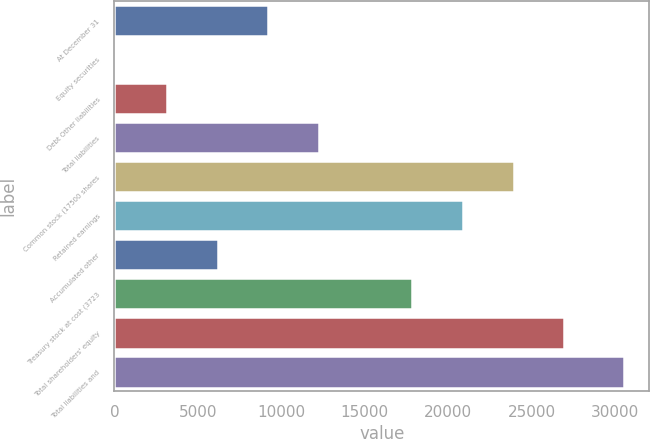<chart> <loc_0><loc_0><loc_500><loc_500><bar_chart><fcel>At December 31<fcel>Equity securities<fcel>Debt Other liabilities<fcel>Total liabilities<fcel>Common stock (17500 shares<fcel>Retained earnings<fcel>Accumulated other<fcel>Treasury stock at cost (3723<fcel>Total shareholders' equity<fcel>Total liabilities and<nl><fcel>9226.9<fcel>94<fcel>3138.3<fcel>12271.2<fcel>23927.6<fcel>20883.3<fcel>6182.6<fcel>17839<fcel>26971.9<fcel>30537<nl></chart> 